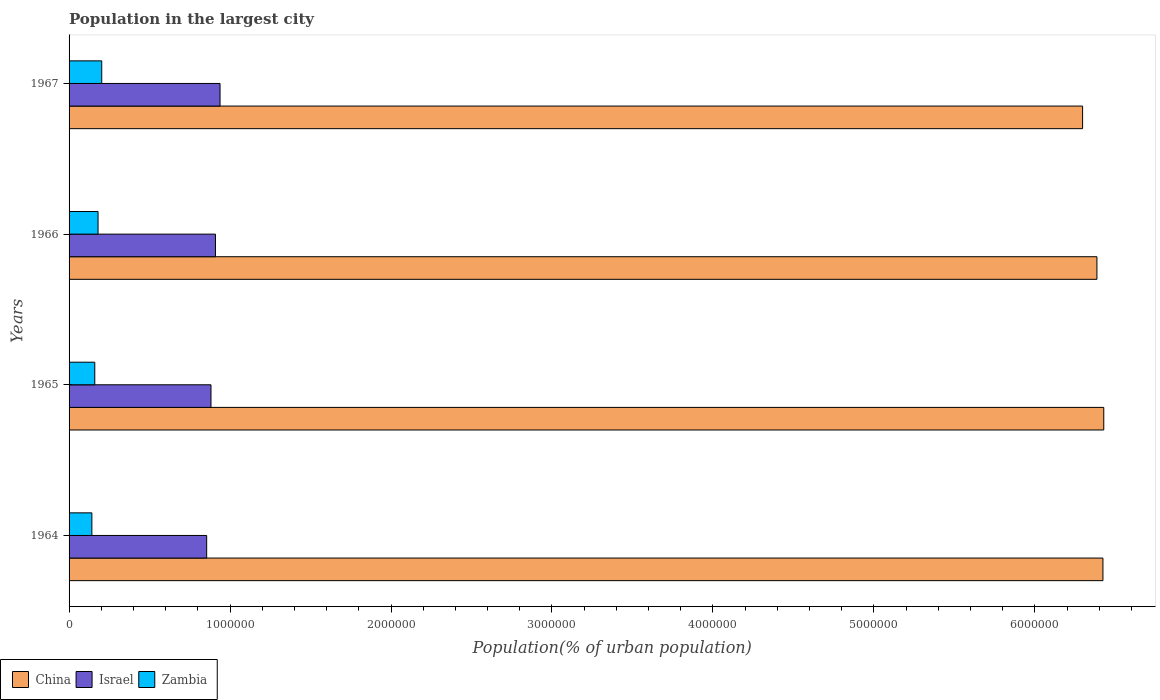How many different coloured bars are there?
Provide a short and direct response. 3. Are the number of bars on each tick of the Y-axis equal?
Your answer should be very brief. Yes. How many bars are there on the 3rd tick from the bottom?
Ensure brevity in your answer.  3. What is the label of the 2nd group of bars from the top?
Your answer should be very brief. 1966. What is the population in the largest city in Israel in 1967?
Offer a terse response. 9.38e+05. Across all years, what is the maximum population in the largest city in Zambia?
Your answer should be very brief. 2.03e+05. Across all years, what is the minimum population in the largest city in Zambia?
Offer a very short reply. 1.42e+05. In which year was the population in the largest city in Israel maximum?
Keep it short and to the point. 1967. In which year was the population in the largest city in China minimum?
Your answer should be compact. 1967. What is the total population in the largest city in Israel in the graph?
Provide a succinct answer. 3.58e+06. What is the difference between the population in the largest city in Israel in 1964 and that in 1965?
Give a very brief answer. -2.68e+04. What is the difference between the population in the largest city in Israel in 1964 and the population in the largest city in Zambia in 1966?
Offer a terse response. 6.75e+05. What is the average population in the largest city in Zambia per year?
Your answer should be very brief. 1.71e+05. In the year 1964, what is the difference between the population in the largest city in Zambia and population in the largest city in China?
Give a very brief answer. -6.28e+06. In how many years, is the population in the largest city in Zambia greater than 2200000 %?
Provide a short and direct response. 0. What is the ratio of the population in the largest city in China in 1966 to that in 1967?
Offer a very short reply. 1.01. Is the population in the largest city in Zambia in 1964 less than that in 1967?
Make the answer very short. Yes. What is the difference between the highest and the second highest population in the largest city in China?
Offer a very short reply. 5114. What is the difference between the highest and the lowest population in the largest city in China?
Make the answer very short. 1.32e+05. Is it the case that in every year, the sum of the population in the largest city in Israel and population in the largest city in China is greater than the population in the largest city in Zambia?
Make the answer very short. Yes. How many years are there in the graph?
Provide a succinct answer. 4. Does the graph contain any zero values?
Offer a terse response. No. Does the graph contain grids?
Your answer should be very brief. No. How are the legend labels stacked?
Provide a succinct answer. Horizontal. What is the title of the graph?
Provide a succinct answer. Population in the largest city. What is the label or title of the X-axis?
Offer a terse response. Population(% of urban population). What is the label or title of the Y-axis?
Ensure brevity in your answer.  Years. What is the Population(% of urban population) of China in 1964?
Make the answer very short. 6.42e+06. What is the Population(% of urban population) of Israel in 1964?
Keep it short and to the point. 8.55e+05. What is the Population(% of urban population) in Zambia in 1964?
Your answer should be very brief. 1.42e+05. What is the Population(% of urban population) of China in 1965?
Make the answer very short. 6.43e+06. What is the Population(% of urban population) in Israel in 1965?
Offer a terse response. 8.82e+05. What is the Population(% of urban population) in Zambia in 1965?
Make the answer very short. 1.60e+05. What is the Population(% of urban population) of China in 1966?
Ensure brevity in your answer.  6.39e+06. What is the Population(% of urban population) of Israel in 1966?
Your answer should be very brief. 9.09e+05. What is the Population(% of urban population) of Zambia in 1966?
Your answer should be very brief. 1.80e+05. What is the Population(% of urban population) of China in 1967?
Your answer should be very brief. 6.30e+06. What is the Population(% of urban population) in Israel in 1967?
Provide a short and direct response. 9.38e+05. What is the Population(% of urban population) of Zambia in 1967?
Your answer should be very brief. 2.03e+05. Across all years, what is the maximum Population(% of urban population) of China?
Make the answer very short. 6.43e+06. Across all years, what is the maximum Population(% of urban population) of Israel?
Provide a short and direct response. 9.38e+05. Across all years, what is the maximum Population(% of urban population) of Zambia?
Give a very brief answer. 2.03e+05. Across all years, what is the minimum Population(% of urban population) of China?
Offer a terse response. 6.30e+06. Across all years, what is the minimum Population(% of urban population) of Israel?
Keep it short and to the point. 8.55e+05. Across all years, what is the minimum Population(% of urban population) of Zambia?
Give a very brief answer. 1.42e+05. What is the total Population(% of urban population) in China in the graph?
Your answer should be compact. 2.55e+07. What is the total Population(% of urban population) of Israel in the graph?
Offer a very short reply. 3.58e+06. What is the total Population(% of urban population) of Zambia in the graph?
Your response must be concise. 6.84e+05. What is the difference between the Population(% of urban population) in China in 1964 and that in 1965?
Keep it short and to the point. -5114. What is the difference between the Population(% of urban population) in Israel in 1964 and that in 1965?
Offer a terse response. -2.68e+04. What is the difference between the Population(% of urban population) in Zambia in 1964 and that in 1965?
Ensure brevity in your answer.  -1.80e+04. What is the difference between the Population(% of urban population) of China in 1964 and that in 1966?
Offer a very short reply. 3.72e+04. What is the difference between the Population(% of urban population) of Israel in 1964 and that in 1966?
Give a very brief answer. -5.45e+04. What is the difference between the Population(% of urban population) in Zambia in 1964 and that in 1966?
Offer a very short reply. -3.84e+04. What is the difference between the Population(% of urban population) of China in 1964 and that in 1967?
Give a very brief answer. 1.26e+05. What is the difference between the Population(% of urban population) of Israel in 1964 and that in 1967?
Offer a terse response. -8.31e+04. What is the difference between the Population(% of urban population) in Zambia in 1964 and that in 1967?
Provide a short and direct response. -6.13e+04. What is the difference between the Population(% of urban population) of China in 1965 and that in 1966?
Your response must be concise. 4.24e+04. What is the difference between the Population(% of urban population) of Israel in 1965 and that in 1966?
Your answer should be compact. -2.77e+04. What is the difference between the Population(% of urban population) in Zambia in 1965 and that in 1966?
Offer a terse response. -2.03e+04. What is the difference between the Population(% of urban population) in China in 1965 and that in 1967?
Provide a succinct answer. 1.32e+05. What is the difference between the Population(% of urban population) in Israel in 1965 and that in 1967?
Ensure brevity in your answer.  -5.63e+04. What is the difference between the Population(% of urban population) of Zambia in 1965 and that in 1967?
Offer a very short reply. -4.33e+04. What is the difference between the Population(% of urban population) of China in 1966 and that in 1967?
Your answer should be compact. 8.92e+04. What is the difference between the Population(% of urban population) of Israel in 1966 and that in 1967?
Give a very brief answer. -2.86e+04. What is the difference between the Population(% of urban population) in Zambia in 1966 and that in 1967?
Make the answer very short. -2.29e+04. What is the difference between the Population(% of urban population) in China in 1964 and the Population(% of urban population) in Israel in 1965?
Your answer should be compact. 5.54e+06. What is the difference between the Population(% of urban population) of China in 1964 and the Population(% of urban population) of Zambia in 1965?
Your response must be concise. 6.26e+06. What is the difference between the Population(% of urban population) in Israel in 1964 and the Population(% of urban population) in Zambia in 1965?
Provide a succinct answer. 6.95e+05. What is the difference between the Population(% of urban population) of China in 1964 and the Population(% of urban population) of Israel in 1966?
Offer a very short reply. 5.51e+06. What is the difference between the Population(% of urban population) of China in 1964 and the Population(% of urban population) of Zambia in 1966?
Offer a terse response. 6.24e+06. What is the difference between the Population(% of urban population) in Israel in 1964 and the Population(% of urban population) in Zambia in 1966?
Your response must be concise. 6.75e+05. What is the difference between the Population(% of urban population) of China in 1964 and the Population(% of urban population) of Israel in 1967?
Offer a terse response. 5.49e+06. What is the difference between the Population(% of urban population) in China in 1964 and the Population(% of urban population) in Zambia in 1967?
Make the answer very short. 6.22e+06. What is the difference between the Population(% of urban population) in Israel in 1964 and the Population(% of urban population) in Zambia in 1967?
Offer a very short reply. 6.52e+05. What is the difference between the Population(% of urban population) in China in 1965 and the Population(% of urban population) in Israel in 1966?
Offer a very short reply. 5.52e+06. What is the difference between the Population(% of urban population) of China in 1965 and the Population(% of urban population) of Zambia in 1966?
Make the answer very short. 6.25e+06. What is the difference between the Population(% of urban population) of Israel in 1965 and the Population(% of urban population) of Zambia in 1966?
Ensure brevity in your answer.  7.02e+05. What is the difference between the Population(% of urban population) of China in 1965 and the Population(% of urban population) of Israel in 1967?
Keep it short and to the point. 5.49e+06. What is the difference between the Population(% of urban population) in China in 1965 and the Population(% of urban population) in Zambia in 1967?
Offer a very short reply. 6.23e+06. What is the difference between the Population(% of urban population) in Israel in 1965 and the Population(% of urban population) in Zambia in 1967?
Your answer should be compact. 6.79e+05. What is the difference between the Population(% of urban population) in China in 1966 and the Population(% of urban population) in Israel in 1967?
Offer a very short reply. 5.45e+06. What is the difference between the Population(% of urban population) in China in 1966 and the Population(% of urban population) in Zambia in 1967?
Your answer should be very brief. 6.18e+06. What is the difference between the Population(% of urban population) of Israel in 1966 and the Population(% of urban population) of Zambia in 1967?
Ensure brevity in your answer.  7.06e+05. What is the average Population(% of urban population) in China per year?
Ensure brevity in your answer.  6.38e+06. What is the average Population(% of urban population) in Israel per year?
Your response must be concise. 8.96e+05. What is the average Population(% of urban population) of Zambia per year?
Give a very brief answer. 1.71e+05. In the year 1964, what is the difference between the Population(% of urban population) in China and Population(% of urban population) in Israel?
Your response must be concise. 5.57e+06. In the year 1964, what is the difference between the Population(% of urban population) of China and Population(% of urban population) of Zambia?
Make the answer very short. 6.28e+06. In the year 1964, what is the difference between the Population(% of urban population) of Israel and Population(% of urban population) of Zambia?
Offer a very short reply. 7.13e+05. In the year 1965, what is the difference between the Population(% of urban population) of China and Population(% of urban population) of Israel?
Offer a terse response. 5.55e+06. In the year 1965, what is the difference between the Population(% of urban population) of China and Population(% of urban population) of Zambia?
Provide a short and direct response. 6.27e+06. In the year 1965, what is the difference between the Population(% of urban population) in Israel and Population(% of urban population) in Zambia?
Provide a short and direct response. 7.22e+05. In the year 1966, what is the difference between the Population(% of urban population) of China and Population(% of urban population) of Israel?
Ensure brevity in your answer.  5.48e+06. In the year 1966, what is the difference between the Population(% of urban population) of China and Population(% of urban population) of Zambia?
Offer a very short reply. 6.21e+06. In the year 1966, what is the difference between the Population(% of urban population) in Israel and Population(% of urban population) in Zambia?
Provide a succinct answer. 7.29e+05. In the year 1967, what is the difference between the Population(% of urban population) of China and Population(% of urban population) of Israel?
Provide a succinct answer. 5.36e+06. In the year 1967, what is the difference between the Population(% of urban population) of China and Population(% of urban population) of Zambia?
Your answer should be compact. 6.09e+06. In the year 1967, what is the difference between the Population(% of urban population) of Israel and Population(% of urban population) of Zambia?
Make the answer very short. 7.35e+05. What is the ratio of the Population(% of urban population) in China in 1964 to that in 1965?
Give a very brief answer. 1. What is the ratio of the Population(% of urban population) of Israel in 1964 to that in 1965?
Give a very brief answer. 0.97. What is the ratio of the Population(% of urban population) in Zambia in 1964 to that in 1965?
Provide a short and direct response. 0.89. What is the ratio of the Population(% of urban population) of Israel in 1964 to that in 1966?
Keep it short and to the point. 0.94. What is the ratio of the Population(% of urban population) in Zambia in 1964 to that in 1966?
Offer a very short reply. 0.79. What is the ratio of the Population(% of urban population) in China in 1964 to that in 1967?
Provide a succinct answer. 1.02. What is the ratio of the Population(% of urban population) in Israel in 1964 to that in 1967?
Provide a succinct answer. 0.91. What is the ratio of the Population(% of urban population) of Zambia in 1964 to that in 1967?
Make the answer very short. 0.7. What is the ratio of the Population(% of urban population) of China in 1965 to that in 1966?
Your answer should be compact. 1.01. What is the ratio of the Population(% of urban population) in Israel in 1965 to that in 1966?
Provide a succinct answer. 0.97. What is the ratio of the Population(% of urban population) in Zambia in 1965 to that in 1966?
Your response must be concise. 0.89. What is the ratio of the Population(% of urban population) in China in 1965 to that in 1967?
Provide a succinct answer. 1.02. What is the ratio of the Population(% of urban population) in Zambia in 1965 to that in 1967?
Your response must be concise. 0.79. What is the ratio of the Population(% of urban population) of China in 1966 to that in 1967?
Keep it short and to the point. 1.01. What is the ratio of the Population(% of urban population) of Israel in 1966 to that in 1967?
Provide a short and direct response. 0.97. What is the ratio of the Population(% of urban population) of Zambia in 1966 to that in 1967?
Provide a succinct answer. 0.89. What is the difference between the highest and the second highest Population(% of urban population) of China?
Keep it short and to the point. 5114. What is the difference between the highest and the second highest Population(% of urban population) in Israel?
Your response must be concise. 2.86e+04. What is the difference between the highest and the second highest Population(% of urban population) in Zambia?
Keep it short and to the point. 2.29e+04. What is the difference between the highest and the lowest Population(% of urban population) of China?
Your answer should be compact. 1.32e+05. What is the difference between the highest and the lowest Population(% of urban population) of Israel?
Your response must be concise. 8.31e+04. What is the difference between the highest and the lowest Population(% of urban population) of Zambia?
Make the answer very short. 6.13e+04. 